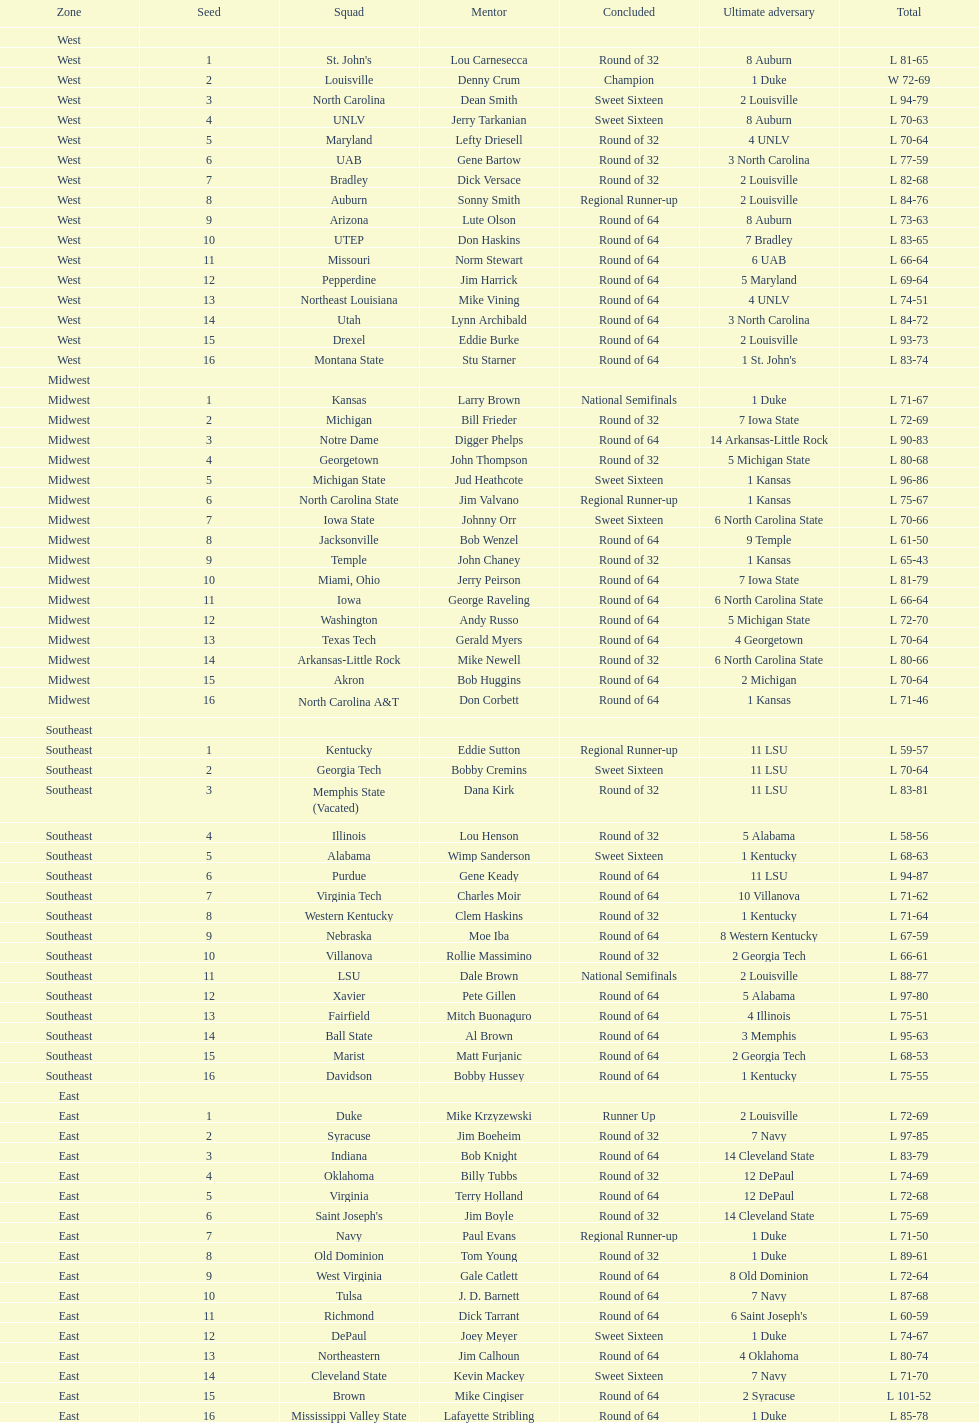What region is listed before the midwest? West. 